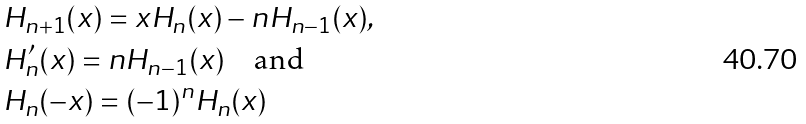<formula> <loc_0><loc_0><loc_500><loc_500>& H _ { n + 1 } ( x ) = x H _ { n } ( x ) - n H _ { n - 1 } ( x ) , \\ & H ^ { \prime } _ { n } ( x ) = n H _ { n - 1 } ( x ) \quad \text {and} \\ & H _ { n } ( - x ) = ( - 1 ) ^ { n } H _ { n } ( x )</formula> 